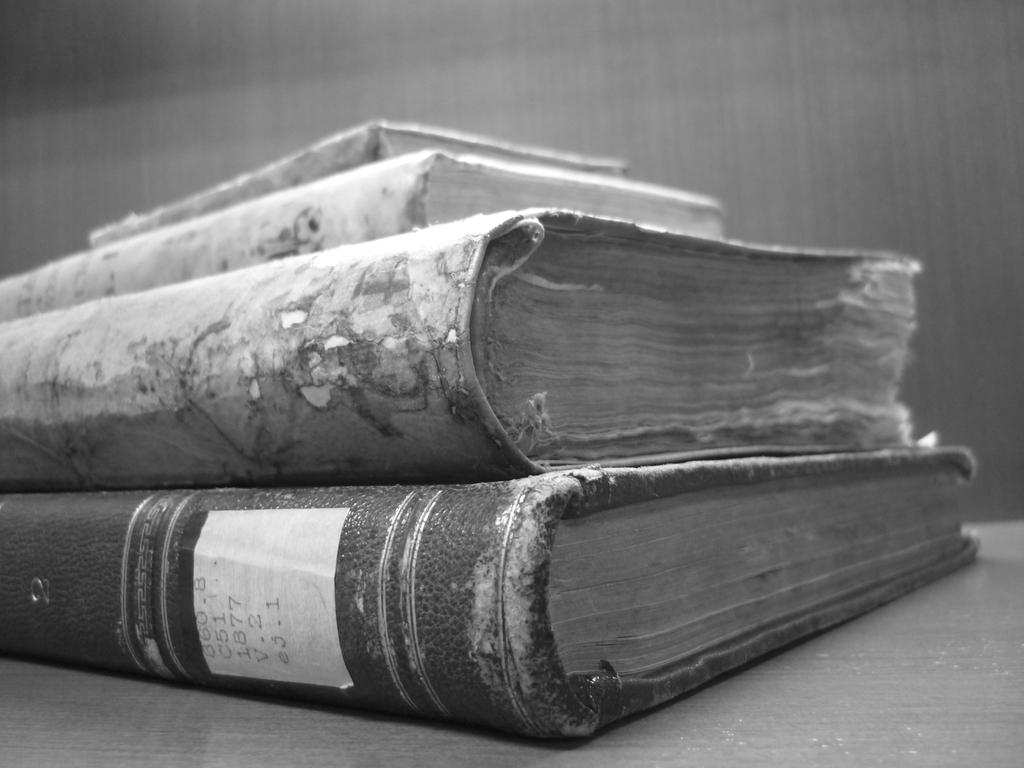What is the color scheme of the image? The image is black and white. What objects can be seen on the table in the image? There are four books on the table. What can be seen in the background of the image? There is a wall visible in the background. What type of order is being processed in the hospital in the image? There is no hospital or order processing visible in the image; it is a black and white image with four books on a table and a wall in the background. 